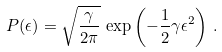<formula> <loc_0><loc_0><loc_500><loc_500>P ( \epsilon ) = \sqrt { \frac { \gamma } { 2 \pi } } \, \exp \left ( - \frac { 1 } { 2 } \gamma \epsilon ^ { 2 } \right ) \, .</formula> 